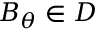Convert formula to latex. <formula><loc_0><loc_0><loc_500><loc_500>B _ { \theta } \in D</formula> 